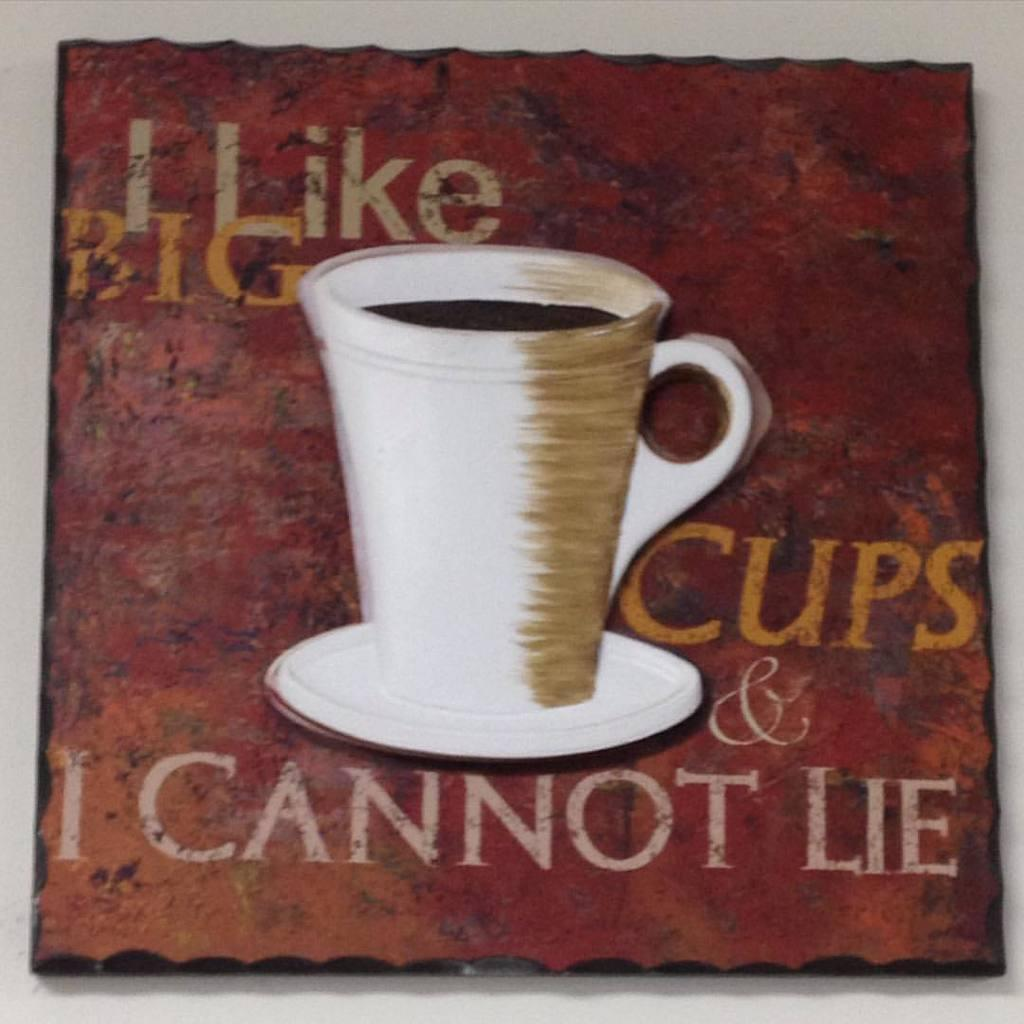<image>
Share a concise interpretation of the image provided. A painting of a coffee cup with the saying that I cannot lie 